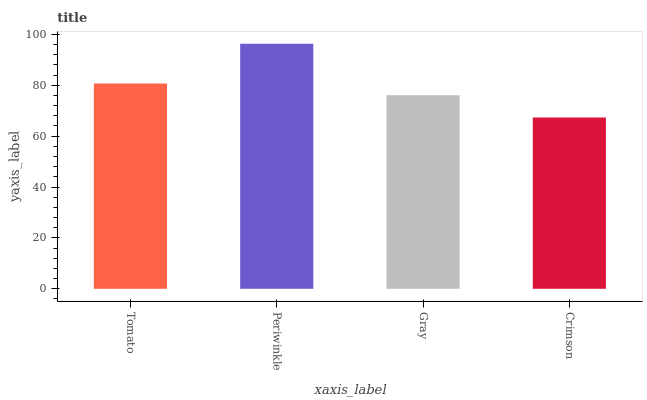Is Crimson the minimum?
Answer yes or no. Yes. Is Periwinkle the maximum?
Answer yes or no. Yes. Is Gray the minimum?
Answer yes or no. No. Is Gray the maximum?
Answer yes or no. No. Is Periwinkle greater than Gray?
Answer yes or no. Yes. Is Gray less than Periwinkle?
Answer yes or no. Yes. Is Gray greater than Periwinkle?
Answer yes or no. No. Is Periwinkle less than Gray?
Answer yes or no. No. Is Tomato the high median?
Answer yes or no. Yes. Is Gray the low median?
Answer yes or no. Yes. Is Gray the high median?
Answer yes or no. No. Is Tomato the low median?
Answer yes or no. No. 